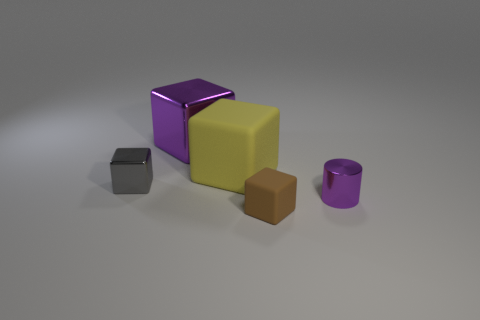Are the big cube that is to the left of the yellow matte object and the yellow object made of the same material? The big cube to the left of the yellow matte object appears to have a reflective surface, which differs from the matte finish of the yellow object. These differences in texture and light reflection suggests that they are not made of the same material. 